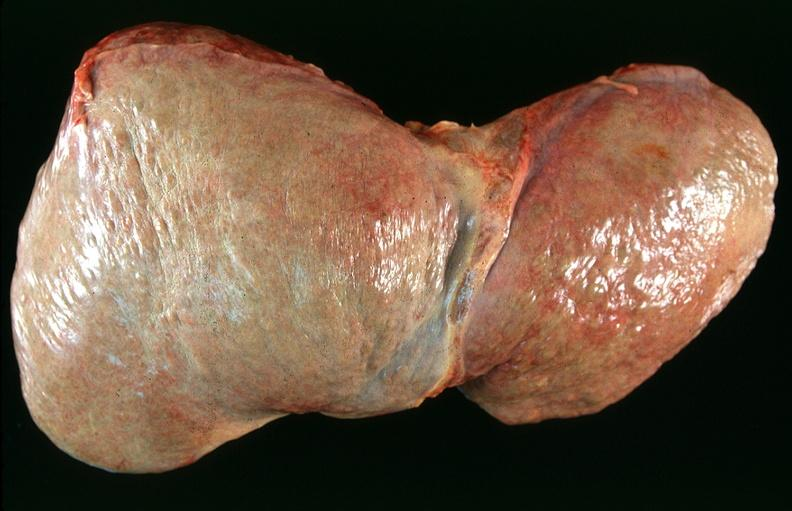s hepatobiliary present?
Answer the question using a single word or phrase. Yes 